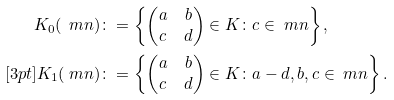<formula> <loc_0><loc_0><loc_500><loc_500>K _ { 0 } ( \ m n ) & \colon = \left \{ \begin{pmatrix} a & b \\ c & d \end{pmatrix} \in K \colon c \in \ m n \right \} , \\ [ 3 p t ] K _ { 1 } ( \ m n ) & \colon = \left \{ \begin{pmatrix} a & b \\ c & d \end{pmatrix} \in K \colon a - d , b , c \in \ m n \right \} .</formula> 